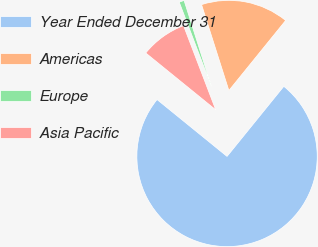<chart> <loc_0><loc_0><loc_500><loc_500><pie_chart><fcel>Year Ended December 31<fcel>Americas<fcel>Europe<fcel>Asia Pacific<nl><fcel>75.02%<fcel>15.74%<fcel>0.91%<fcel>8.33%<nl></chart> 